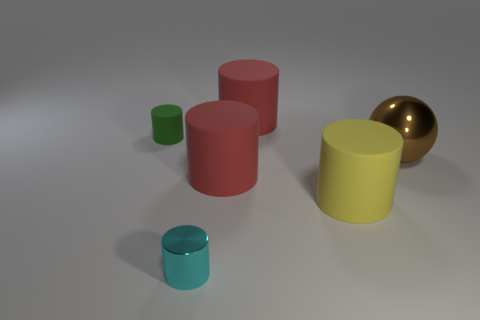Subtract all yellow cubes. How many red cylinders are left? 2 Subtract all red rubber cylinders. How many cylinders are left? 3 Add 3 red rubber cylinders. How many objects exist? 9 Subtract all yellow cylinders. How many cylinders are left? 4 Subtract 1 cylinders. How many cylinders are left? 4 Subtract all balls. How many objects are left? 5 Subtract all cyan balls. Subtract all green cubes. How many balls are left? 1 Subtract all tiny red shiny balls. Subtract all big yellow things. How many objects are left? 5 Add 1 large red objects. How many large red objects are left? 3 Add 1 tiny brown metal cylinders. How many tiny brown metal cylinders exist? 1 